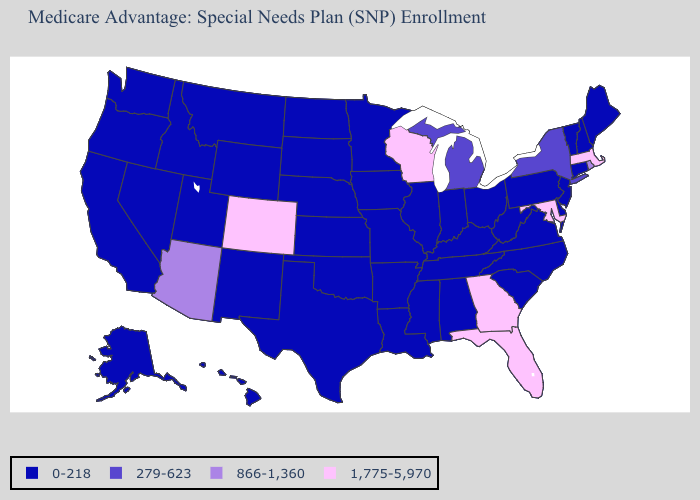Name the states that have a value in the range 866-1,360?
Give a very brief answer. Arizona, Rhode Island. Name the states that have a value in the range 1,775-5,970?
Give a very brief answer. Colorado, Florida, Georgia, Massachusetts, Maryland, Wisconsin. What is the value of North Dakota?
Concise answer only. 0-218. What is the value of Missouri?
Answer briefly. 0-218. What is the highest value in the USA?
Keep it brief. 1,775-5,970. What is the lowest value in the West?
Concise answer only. 0-218. Among the states that border New Mexico , which have the lowest value?
Give a very brief answer. Oklahoma, Texas, Utah. What is the value of New Jersey?
Give a very brief answer. 0-218. Among the states that border Delaware , which have the highest value?
Quick response, please. Maryland. Name the states that have a value in the range 1,775-5,970?
Quick response, please. Colorado, Florida, Georgia, Massachusetts, Maryland, Wisconsin. What is the value of Minnesota?
Concise answer only. 0-218. What is the lowest value in the USA?
Be succinct. 0-218. Name the states that have a value in the range 279-623?
Be succinct. Michigan, New York. What is the value of North Dakota?
Concise answer only. 0-218. Does Colorado have the lowest value in the West?
Be succinct. No. 